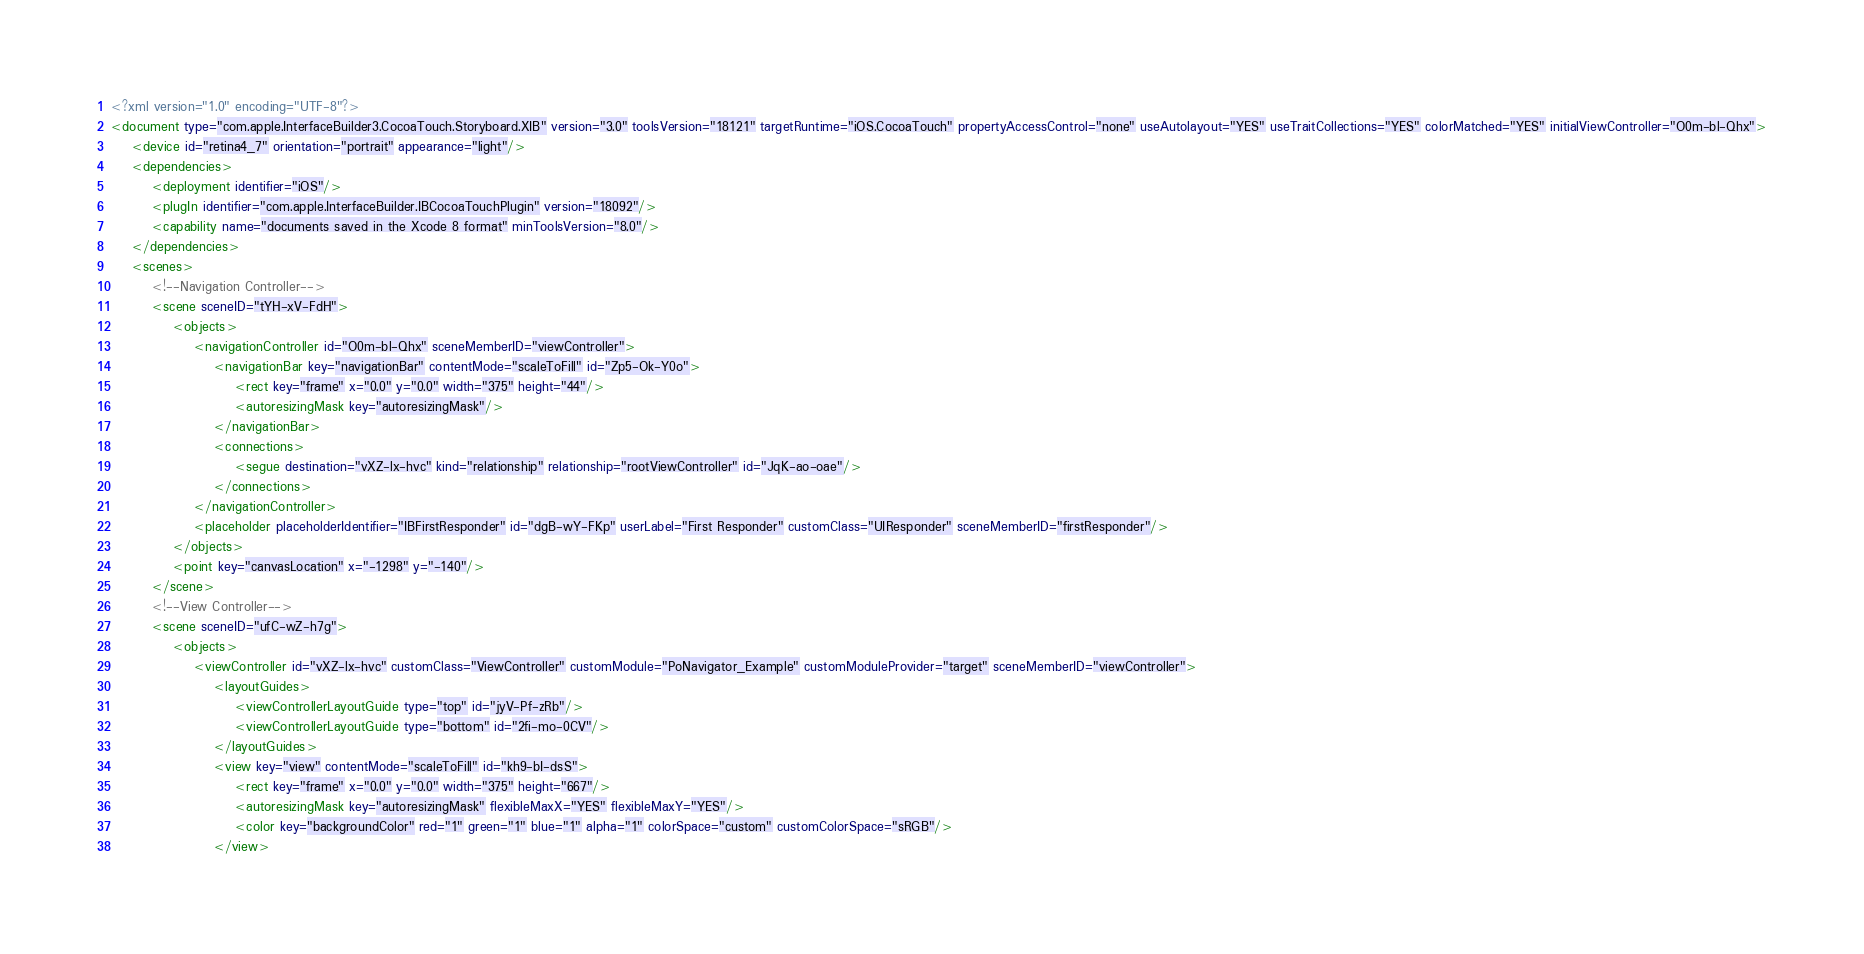Convert code to text. <code><loc_0><loc_0><loc_500><loc_500><_XML_><?xml version="1.0" encoding="UTF-8"?>
<document type="com.apple.InterfaceBuilder3.CocoaTouch.Storyboard.XIB" version="3.0" toolsVersion="18121" targetRuntime="iOS.CocoaTouch" propertyAccessControl="none" useAutolayout="YES" useTraitCollections="YES" colorMatched="YES" initialViewController="O0m-bl-Qhx">
    <device id="retina4_7" orientation="portrait" appearance="light"/>
    <dependencies>
        <deployment identifier="iOS"/>
        <plugIn identifier="com.apple.InterfaceBuilder.IBCocoaTouchPlugin" version="18092"/>
        <capability name="documents saved in the Xcode 8 format" minToolsVersion="8.0"/>
    </dependencies>
    <scenes>
        <!--Navigation Controller-->
        <scene sceneID="tYH-xV-FdH">
            <objects>
                <navigationController id="O0m-bl-Qhx" sceneMemberID="viewController">
                    <navigationBar key="navigationBar" contentMode="scaleToFill" id="Zp5-Ok-Y0o">
                        <rect key="frame" x="0.0" y="0.0" width="375" height="44"/>
                        <autoresizingMask key="autoresizingMask"/>
                    </navigationBar>
                    <connections>
                        <segue destination="vXZ-lx-hvc" kind="relationship" relationship="rootViewController" id="JqK-ao-oae"/>
                    </connections>
                </navigationController>
                <placeholder placeholderIdentifier="IBFirstResponder" id="dgB-wY-FKp" userLabel="First Responder" customClass="UIResponder" sceneMemberID="firstResponder"/>
            </objects>
            <point key="canvasLocation" x="-1298" y="-140"/>
        </scene>
        <!--View Controller-->
        <scene sceneID="ufC-wZ-h7g">
            <objects>
                <viewController id="vXZ-lx-hvc" customClass="ViewController" customModule="PoNavigator_Example" customModuleProvider="target" sceneMemberID="viewController">
                    <layoutGuides>
                        <viewControllerLayoutGuide type="top" id="jyV-Pf-zRb"/>
                        <viewControllerLayoutGuide type="bottom" id="2fi-mo-0CV"/>
                    </layoutGuides>
                    <view key="view" contentMode="scaleToFill" id="kh9-bI-dsS">
                        <rect key="frame" x="0.0" y="0.0" width="375" height="667"/>
                        <autoresizingMask key="autoresizingMask" flexibleMaxX="YES" flexibleMaxY="YES"/>
                        <color key="backgroundColor" red="1" green="1" blue="1" alpha="1" colorSpace="custom" customColorSpace="sRGB"/>
                    </view></code> 